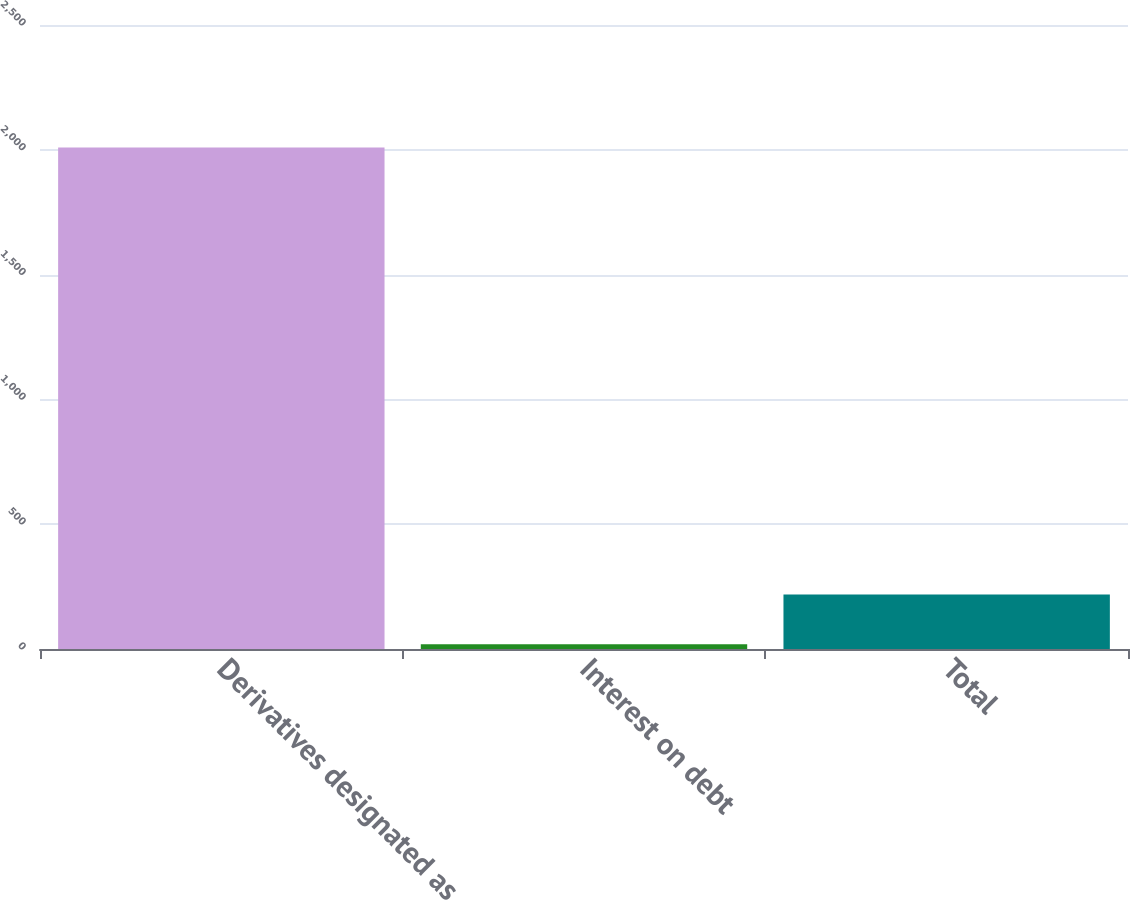Convert chart. <chart><loc_0><loc_0><loc_500><loc_500><bar_chart><fcel>Derivatives designated as<fcel>Interest on debt<fcel>Total<nl><fcel>2009<fcel>19<fcel>218<nl></chart> 